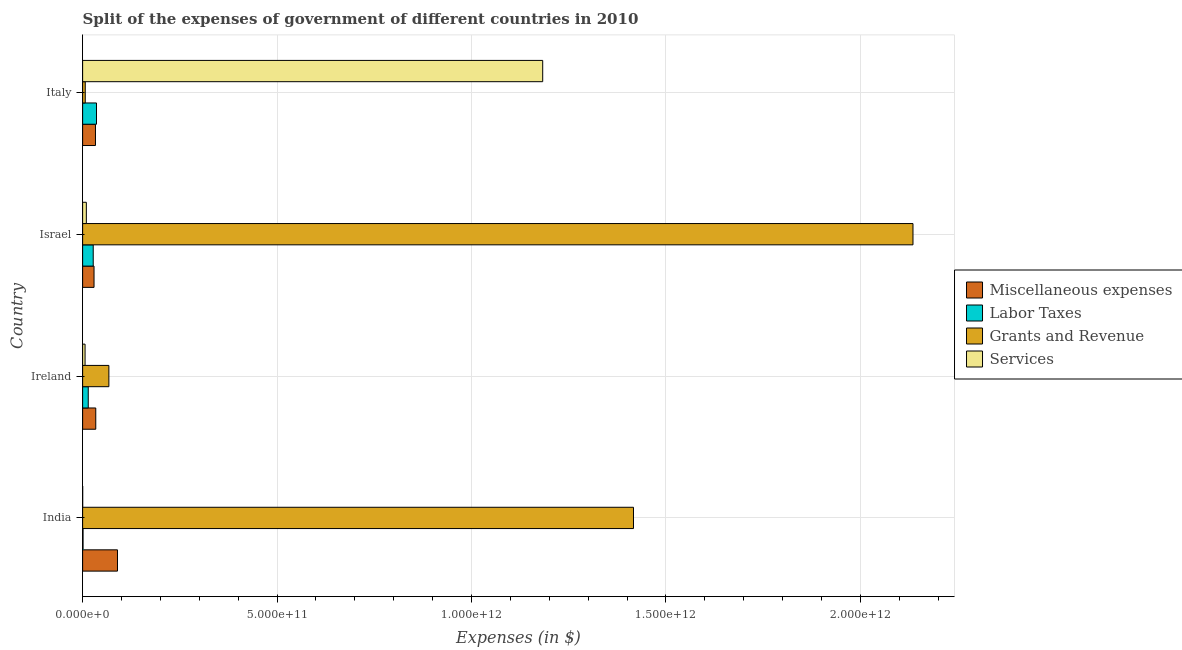How many different coloured bars are there?
Ensure brevity in your answer.  4. Are the number of bars per tick equal to the number of legend labels?
Ensure brevity in your answer.  Yes. How many bars are there on the 3rd tick from the top?
Provide a short and direct response. 4. What is the label of the 3rd group of bars from the top?
Offer a very short reply. Ireland. In how many cases, is the number of bars for a given country not equal to the number of legend labels?
Your answer should be very brief. 0. What is the amount spent on miscellaneous expenses in India?
Offer a very short reply. 8.96e+1. Across all countries, what is the maximum amount spent on labor taxes?
Provide a short and direct response. 3.57e+1. Across all countries, what is the minimum amount spent on grants and revenue?
Your answer should be very brief. 6.71e+09. In which country was the amount spent on services maximum?
Your answer should be compact. Italy. What is the total amount spent on services in the graph?
Your answer should be very brief. 1.20e+12. What is the difference between the amount spent on miscellaneous expenses in Ireland and that in Israel?
Give a very brief answer. 4.46e+09. What is the difference between the amount spent on grants and revenue in Ireland and the amount spent on miscellaneous expenses in India?
Your answer should be very brief. -2.22e+1. What is the average amount spent on miscellaneous expenses per country?
Ensure brevity in your answer.  4.64e+1. What is the difference between the amount spent on miscellaneous expenses and amount spent on services in Ireland?
Give a very brief answer. 2.75e+1. What is the ratio of the amount spent on labor taxes in India to that in Israel?
Provide a succinct answer. 0.04. Is the amount spent on labor taxes in India less than that in Israel?
Your response must be concise. Yes. What is the difference between the highest and the second highest amount spent on labor taxes?
Provide a succinct answer. 8.45e+09. What is the difference between the highest and the lowest amount spent on services?
Offer a very short reply. 1.18e+12. In how many countries, is the amount spent on miscellaneous expenses greater than the average amount spent on miscellaneous expenses taken over all countries?
Offer a terse response. 1. Is the sum of the amount spent on labor taxes in India and Italy greater than the maximum amount spent on grants and revenue across all countries?
Offer a terse response. No. What does the 1st bar from the top in Italy represents?
Provide a succinct answer. Services. What does the 1st bar from the bottom in Israel represents?
Offer a terse response. Miscellaneous expenses. Are all the bars in the graph horizontal?
Your response must be concise. Yes. What is the difference between two consecutive major ticks on the X-axis?
Provide a succinct answer. 5.00e+11. Does the graph contain any zero values?
Give a very brief answer. No. How many legend labels are there?
Offer a very short reply. 4. What is the title of the graph?
Provide a succinct answer. Split of the expenses of government of different countries in 2010. Does "Other Minerals" appear as one of the legend labels in the graph?
Provide a short and direct response. No. What is the label or title of the X-axis?
Your answer should be very brief. Expenses (in $). What is the label or title of the Y-axis?
Keep it short and to the point. Country. What is the Expenses (in $) in Miscellaneous expenses in India?
Give a very brief answer. 8.96e+1. What is the Expenses (in $) in Labor Taxes in India?
Your answer should be very brief. 1.06e+09. What is the Expenses (in $) in Grants and Revenue in India?
Make the answer very short. 1.42e+12. What is the Expenses (in $) of Services in India?
Ensure brevity in your answer.  9.19e+07. What is the Expenses (in $) in Miscellaneous expenses in Ireland?
Provide a short and direct response. 3.38e+1. What is the Expenses (in $) in Labor Taxes in Ireland?
Offer a very short reply. 1.44e+1. What is the Expenses (in $) in Grants and Revenue in Ireland?
Your response must be concise. 6.75e+1. What is the Expenses (in $) in Services in Ireland?
Ensure brevity in your answer.  6.24e+09. What is the Expenses (in $) of Miscellaneous expenses in Israel?
Ensure brevity in your answer.  2.93e+1. What is the Expenses (in $) in Labor Taxes in Israel?
Offer a very short reply. 2.72e+1. What is the Expenses (in $) of Grants and Revenue in Israel?
Give a very brief answer. 2.14e+12. What is the Expenses (in $) of Services in Israel?
Your response must be concise. 9.53e+09. What is the Expenses (in $) of Miscellaneous expenses in Italy?
Provide a succinct answer. 3.30e+1. What is the Expenses (in $) of Labor Taxes in Italy?
Your answer should be very brief. 3.57e+1. What is the Expenses (in $) of Grants and Revenue in Italy?
Give a very brief answer. 6.71e+09. What is the Expenses (in $) of Services in Italy?
Keep it short and to the point. 1.18e+12. Across all countries, what is the maximum Expenses (in $) of Miscellaneous expenses?
Your answer should be very brief. 8.96e+1. Across all countries, what is the maximum Expenses (in $) in Labor Taxes?
Give a very brief answer. 3.57e+1. Across all countries, what is the maximum Expenses (in $) in Grants and Revenue?
Your response must be concise. 2.14e+12. Across all countries, what is the maximum Expenses (in $) of Services?
Keep it short and to the point. 1.18e+12. Across all countries, what is the minimum Expenses (in $) in Miscellaneous expenses?
Provide a succinct answer. 2.93e+1. Across all countries, what is the minimum Expenses (in $) of Labor Taxes?
Provide a short and direct response. 1.06e+09. Across all countries, what is the minimum Expenses (in $) of Grants and Revenue?
Give a very brief answer. 6.71e+09. Across all countries, what is the minimum Expenses (in $) in Services?
Keep it short and to the point. 9.19e+07. What is the total Expenses (in $) of Miscellaneous expenses in the graph?
Ensure brevity in your answer.  1.86e+11. What is the total Expenses (in $) in Labor Taxes in the graph?
Provide a short and direct response. 7.84e+1. What is the total Expenses (in $) in Grants and Revenue in the graph?
Offer a very short reply. 3.63e+12. What is the total Expenses (in $) of Services in the graph?
Make the answer very short. 1.20e+12. What is the difference between the Expenses (in $) in Miscellaneous expenses in India and that in Ireland?
Provide a short and direct response. 5.59e+1. What is the difference between the Expenses (in $) of Labor Taxes in India and that in Ireland?
Provide a succinct answer. -1.34e+1. What is the difference between the Expenses (in $) in Grants and Revenue in India and that in Ireland?
Your response must be concise. 1.35e+12. What is the difference between the Expenses (in $) in Services in India and that in Ireland?
Give a very brief answer. -6.15e+09. What is the difference between the Expenses (in $) of Miscellaneous expenses in India and that in Israel?
Ensure brevity in your answer.  6.03e+1. What is the difference between the Expenses (in $) in Labor Taxes in India and that in Israel?
Your answer should be very brief. -2.62e+1. What is the difference between the Expenses (in $) in Grants and Revenue in India and that in Israel?
Give a very brief answer. -7.19e+11. What is the difference between the Expenses (in $) in Services in India and that in Israel?
Offer a terse response. -9.44e+09. What is the difference between the Expenses (in $) of Miscellaneous expenses in India and that in Italy?
Provide a short and direct response. 5.66e+1. What is the difference between the Expenses (in $) in Labor Taxes in India and that in Italy?
Make the answer very short. -3.46e+1. What is the difference between the Expenses (in $) of Grants and Revenue in India and that in Italy?
Ensure brevity in your answer.  1.41e+12. What is the difference between the Expenses (in $) of Services in India and that in Italy?
Offer a very short reply. -1.18e+12. What is the difference between the Expenses (in $) of Miscellaneous expenses in Ireland and that in Israel?
Keep it short and to the point. 4.46e+09. What is the difference between the Expenses (in $) in Labor Taxes in Ireland and that in Israel?
Your answer should be compact. -1.28e+1. What is the difference between the Expenses (in $) in Grants and Revenue in Ireland and that in Israel?
Keep it short and to the point. -2.07e+12. What is the difference between the Expenses (in $) of Services in Ireland and that in Israel?
Make the answer very short. -3.29e+09. What is the difference between the Expenses (in $) in Miscellaneous expenses in Ireland and that in Italy?
Offer a very short reply. 7.56e+08. What is the difference between the Expenses (in $) of Labor Taxes in Ireland and that in Italy?
Offer a terse response. -2.12e+1. What is the difference between the Expenses (in $) in Grants and Revenue in Ireland and that in Italy?
Keep it short and to the point. 6.08e+1. What is the difference between the Expenses (in $) in Services in Ireland and that in Italy?
Offer a very short reply. -1.18e+12. What is the difference between the Expenses (in $) in Miscellaneous expenses in Israel and that in Italy?
Provide a succinct answer. -3.71e+09. What is the difference between the Expenses (in $) of Labor Taxes in Israel and that in Italy?
Your answer should be compact. -8.45e+09. What is the difference between the Expenses (in $) of Grants and Revenue in Israel and that in Italy?
Ensure brevity in your answer.  2.13e+12. What is the difference between the Expenses (in $) of Services in Israel and that in Italy?
Offer a terse response. -1.17e+12. What is the difference between the Expenses (in $) in Miscellaneous expenses in India and the Expenses (in $) in Labor Taxes in Ireland?
Provide a short and direct response. 7.52e+1. What is the difference between the Expenses (in $) of Miscellaneous expenses in India and the Expenses (in $) of Grants and Revenue in Ireland?
Provide a succinct answer. 2.22e+1. What is the difference between the Expenses (in $) in Miscellaneous expenses in India and the Expenses (in $) in Services in Ireland?
Provide a succinct answer. 8.34e+1. What is the difference between the Expenses (in $) of Labor Taxes in India and the Expenses (in $) of Grants and Revenue in Ireland?
Provide a succinct answer. -6.64e+1. What is the difference between the Expenses (in $) in Labor Taxes in India and the Expenses (in $) in Services in Ireland?
Your answer should be very brief. -5.18e+09. What is the difference between the Expenses (in $) in Grants and Revenue in India and the Expenses (in $) in Services in Ireland?
Your answer should be very brief. 1.41e+12. What is the difference between the Expenses (in $) of Miscellaneous expenses in India and the Expenses (in $) of Labor Taxes in Israel?
Offer a very short reply. 6.24e+1. What is the difference between the Expenses (in $) of Miscellaneous expenses in India and the Expenses (in $) of Grants and Revenue in Israel?
Keep it short and to the point. -2.05e+12. What is the difference between the Expenses (in $) in Miscellaneous expenses in India and the Expenses (in $) in Services in Israel?
Your answer should be compact. 8.01e+1. What is the difference between the Expenses (in $) in Labor Taxes in India and the Expenses (in $) in Grants and Revenue in Israel?
Provide a short and direct response. -2.13e+12. What is the difference between the Expenses (in $) in Labor Taxes in India and the Expenses (in $) in Services in Israel?
Your answer should be compact. -8.47e+09. What is the difference between the Expenses (in $) of Grants and Revenue in India and the Expenses (in $) of Services in Israel?
Provide a short and direct response. 1.41e+12. What is the difference between the Expenses (in $) of Miscellaneous expenses in India and the Expenses (in $) of Labor Taxes in Italy?
Your answer should be compact. 5.40e+1. What is the difference between the Expenses (in $) of Miscellaneous expenses in India and the Expenses (in $) of Grants and Revenue in Italy?
Give a very brief answer. 8.29e+1. What is the difference between the Expenses (in $) in Miscellaneous expenses in India and the Expenses (in $) in Services in Italy?
Offer a terse response. -1.09e+12. What is the difference between the Expenses (in $) in Labor Taxes in India and the Expenses (in $) in Grants and Revenue in Italy?
Make the answer very short. -5.66e+09. What is the difference between the Expenses (in $) in Labor Taxes in India and the Expenses (in $) in Services in Italy?
Provide a succinct answer. -1.18e+12. What is the difference between the Expenses (in $) of Grants and Revenue in India and the Expenses (in $) of Services in Italy?
Your answer should be very brief. 2.33e+11. What is the difference between the Expenses (in $) in Miscellaneous expenses in Ireland and the Expenses (in $) in Labor Taxes in Israel?
Keep it short and to the point. 6.55e+09. What is the difference between the Expenses (in $) in Miscellaneous expenses in Ireland and the Expenses (in $) in Grants and Revenue in Israel?
Your answer should be compact. -2.10e+12. What is the difference between the Expenses (in $) of Miscellaneous expenses in Ireland and the Expenses (in $) of Services in Israel?
Give a very brief answer. 2.42e+1. What is the difference between the Expenses (in $) of Labor Taxes in Ireland and the Expenses (in $) of Grants and Revenue in Israel?
Keep it short and to the point. -2.12e+12. What is the difference between the Expenses (in $) in Labor Taxes in Ireland and the Expenses (in $) in Services in Israel?
Your answer should be compact. 4.90e+09. What is the difference between the Expenses (in $) of Grants and Revenue in Ireland and the Expenses (in $) of Services in Israel?
Offer a terse response. 5.79e+1. What is the difference between the Expenses (in $) of Miscellaneous expenses in Ireland and the Expenses (in $) of Labor Taxes in Italy?
Your response must be concise. -1.90e+09. What is the difference between the Expenses (in $) of Miscellaneous expenses in Ireland and the Expenses (in $) of Grants and Revenue in Italy?
Your answer should be compact. 2.71e+1. What is the difference between the Expenses (in $) in Miscellaneous expenses in Ireland and the Expenses (in $) in Services in Italy?
Give a very brief answer. -1.15e+12. What is the difference between the Expenses (in $) in Labor Taxes in Ireland and the Expenses (in $) in Grants and Revenue in Italy?
Your answer should be very brief. 7.72e+09. What is the difference between the Expenses (in $) of Labor Taxes in Ireland and the Expenses (in $) of Services in Italy?
Offer a very short reply. -1.17e+12. What is the difference between the Expenses (in $) of Grants and Revenue in Ireland and the Expenses (in $) of Services in Italy?
Provide a succinct answer. -1.12e+12. What is the difference between the Expenses (in $) of Miscellaneous expenses in Israel and the Expenses (in $) of Labor Taxes in Italy?
Your response must be concise. -6.36e+09. What is the difference between the Expenses (in $) in Miscellaneous expenses in Israel and the Expenses (in $) in Grants and Revenue in Italy?
Ensure brevity in your answer.  2.26e+1. What is the difference between the Expenses (in $) in Miscellaneous expenses in Israel and the Expenses (in $) in Services in Italy?
Offer a very short reply. -1.15e+12. What is the difference between the Expenses (in $) of Labor Taxes in Israel and the Expenses (in $) of Grants and Revenue in Italy?
Give a very brief answer. 2.05e+1. What is the difference between the Expenses (in $) in Labor Taxes in Israel and the Expenses (in $) in Services in Italy?
Offer a very short reply. -1.16e+12. What is the difference between the Expenses (in $) of Grants and Revenue in Israel and the Expenses (in $) of Services in Italy?
Give a very brief answer. 9.52e+11. What is the average Expenses (in $) of Miscellaneous expenses per country?
Ensure brevity in your answer.  4.64e+1. What is the average Expenses (in $) in Labor Taxes per country?
Ensure brevity in your answer.  1.96e+1. What is the average Expenses (in $) of Grants and Revenue per country?
Your answer should be compact. 9.06e+11. What is the average Expenses (in $) in Services per country?
Provide a succinct answer. 3.00e+11. What is the difference between the Expenses (in $) in Miscellaneous expenses and Expenses (in $) in Labor Taxes in India?
Give a very brief answer. 8.86e+1. What is the difference between the Expenses (in $) in Miscellaneous expenses and Expenses (in $) in Grants and Revenue in India?
Make the answer very short. -1.33e+12. What is the difference between the Expenses (in $) in Miscellaneous expenses and Expenses (in $) in Services in India?
Your answer should be very brief. 8.95e+1. What is the difference between the Expenses (in $) of Labor Taxes and Expenses (in $) of Grants and Revenue in India?
Offer a terse response. -1.42e+12. What is the difference between the Expenses (in $) in Labor Taxes and Expenses (in $) in Services in India?
Your response must be concise. 9.65e+08. What is the difference between the Expenses (in $) of Grants and Revenue and Expenses (in $) of Services in India?
Provide a short and direct response. 1.42e+12. What is the difference between the Expenses (in $) in Miscellaneous expenses and Expenses (in $) in Labor Taxes in Ireland?
Ensure brevity in your answer.  1.93e+1. What is the difference between the Expenses (in $) in Miscellaneous expenses and Expenses (in $) in Grants and Revenue in Ireland?
Offer a very short reply. -3.37e+1. What is the difference between the Expenses (in $) in Miscellaneous expenses and Expenses (in $) in Services in Ireland?
Ensure brevity in your answer.  2.75e+1. What is the difference between the Expenses (in $) in Labor Taxes and Expenses (in $) in Grants and Revenue in Ireland?
Ensure brevity in your answer.  -5.31e+1. What is the difference between the Expenses (in $) in Labor Taxes and Expenses (in $) in Services in Ireland?
Provide a short and direct response. 8.19e+09. What is the difference between the Expenses (in $) in Grants and Revenue and Expenses (in $) in Services in Ireland?
Your response must be concise. 6.12e+1. What is the difference between the Expenses (in $) of Miscellaneous expenses and Expenses (in $) of Labor Taxes in Israel?
Provide a short and direct response. 2.09e+09. What is the difference between the Expenses (in $) in Miscellaneous expenses and Expenses (in $) in Grants and Revenue in Israel?
Ensure brevity in your answer.  -2.11e+12. What is the difference between the Expenses (in $) in Miscellaneous expenses and Expenses (in $) in Services in Israel?
Your response must be concise. 1.98e+1. What is the difference between the Expenses (in $) in Labor Taxes and Expenses (in $) in Grants and Revenue in Israel?
Your response must be concise. -2.11e+12. What is the difference between the Expenses (in $) in Labor Taxes and Expenses (in $) in Services in Israel?
Make the answer very short. 1.77e+1. What is the difference between the Expenses (in $) in Grants and Revenue and Expenses (in $) in Services in Israel?
Your answer should be very brief. 2.13e+12. What is the difference between the Expenses (in $) of Miscellaneous expenses and Expenses (in $) of Labor Taxes in Italy?
Give a very brief answer. -2.66e+09. What is the difference between the Expenses (in $) of Miscellaneous expenses and Expenses (in $) of Grants and Revenue in Italy?
Your answer should be very brief. 2.63e+1. What is the difference between the Expenses (in $) in Miscellaneous expenses and Expenses (in $) in Services in Italy?
Ensure brevity in your answer.  -1.15e+12. What is the difference between the Expenses (in $) of Labor Taxes and Expenses (in $) of Grants and Revenue in Italy?
Your response must be concise. 2.90e+1. What is the difference between the Expenses (in $) in Labor Taxes and Expenses (in $) in Services in Italy?
Your answer should be very brief. -1.15e+12. What is the difference between the Expenses (in $) of Grants and Revenue and Expenses (in $) of Services in Italy?
Offer a terse response. -1.18e+12. What is the ratio of the Expenses (in $) in Miscellaneous expenses in India to that in Ireland?
Your response must be concise. 2.65. What is the ratio of the Expenses (in $) of Labor Taxes in India to that in Ireland?
Your answer should be compact. 0.07. What is the ratio of the Expenses (in $) of Grants and Revenue in India to that in Ireland?
Give a very brief answer. 20.99. What is the ratio of the Expenses (in $) in Services in India to that in Ireland?
Offer a very short reply. 0.01. What is the ratio of the Expenses (in $) of Miscellaneous expenses in India to that in Israel?
Your answer should be very brief. 3.06. What is the ratio of the Expenses (in $) of Labor Taxes in India to that in Israel?
Your response must be concise. 0.04. What is the ratio of the Expenses (in $) in Grants and Revenue in India to that in Israel?
Provide a short and direct response. 0.66. What is the ratio of the Expenses (in $) of Services in India to that in Israel?
Your answer should be very brief. 0.01. What is the ratio of the Expenses (in $) of Miscellaneous expenses in India to that in Italy?
Provide a succinct answer. 2.71. What is the ratio of the Expenses (in $) in Labor Taxes in India to that in Italy?
Provide a short and direct response. 0.03. What is the ratio of the Expenses (in $) of Grants and Revenue in India to that in Italy?
Give a very brief answer. 211. What is the ratio of the Expenses (in $) of Services in India to that in Italy?
Give a very brief answer. 0. What is the ratio of the Expenses (in $) of Miscellaneous expenses in Ireland to that in Israel?
Offer a terse response. 1.15. What is the ratio of the Expenses (in $) in Labor Taxes in Ireland to that in Israel?
Make the answer very short. 0.53. What is the ratio of the Expenses (in $) of Grants and Revenue in Ireland to that in Israel?
Offer a terse response. 0.03. What is the ratio of the Expenses (in $) of Services in Ireland to that in Israel?
Give a very brief answer. 0.66. What is the ratio of the Expenses (in $) of Miscellaneous expenses in Ireland to that in Italy?
Provide a succinct answer. 1.02. What is the ratio of the Expenses (in $) in Labor Taxes in Ireland to that in Italy?
Offer a very short reply. 0.4. What is the ratio of the Expenses (in $) in Grants and Revenue in Ireland to that in Italy?
Your answer should be very brief. 10.05. What is the ratio of the Expenses (in $) in Services in Ireland to that in Italy?
Offer a very short reply. 0.01. What is the ratio of the Expenses (in $) of Miscellaneous expenses in Israel to that in Italy?
Keep it short and to the point. 0.89. What is the ratio of the Expenses (in $) of Labor Taxes in Israel to that in Italy?
Make the answer very short. 0.76. What is the ratio of the Expenses (in $) of Grants and Revenue in Israel to that in Italy?
Give a very brief answer. 318.06. What is the ratio of the Expenses (in $) of Services in Israel to that in Italy?
Make the answer very short. 0.01. What is the difference between the highest and the second highest Expenses (in $) of Miscellaneous expenses?
Ensure brevity in your answer.  5.59e+1. What is the difference between the highest and the second highest Expenses (in $) in Labor Taxes?
Your answer should be compact. 8.45e+09. What is the difference between the highest and the second highest Expenses (in $) of Grants and Revenue?
Give a very brief answer. 7.19e+11. What is the difference between the highest and the second highest Expenses (in $) in Services?
Give a very brief answer. 1.17e+12. What is the difference between the highest and the lowest Expenses (in $) in Miscellaneous expenses?
Your response must be concise. 6.03e+1. What is the difference between the highest and the lowest Expenses (in $) of Labor Taxes?
Offer a terse response. 3.46e+1. What is the difference between the highest and the lowest Expenses (in $) of Grants and Revenue?
Your response must be concise. 2.13e+12. What is the difference between the highest and the lowest Expenses (in $) of Services?
Your answer should be very brief. 1.18e+12. 